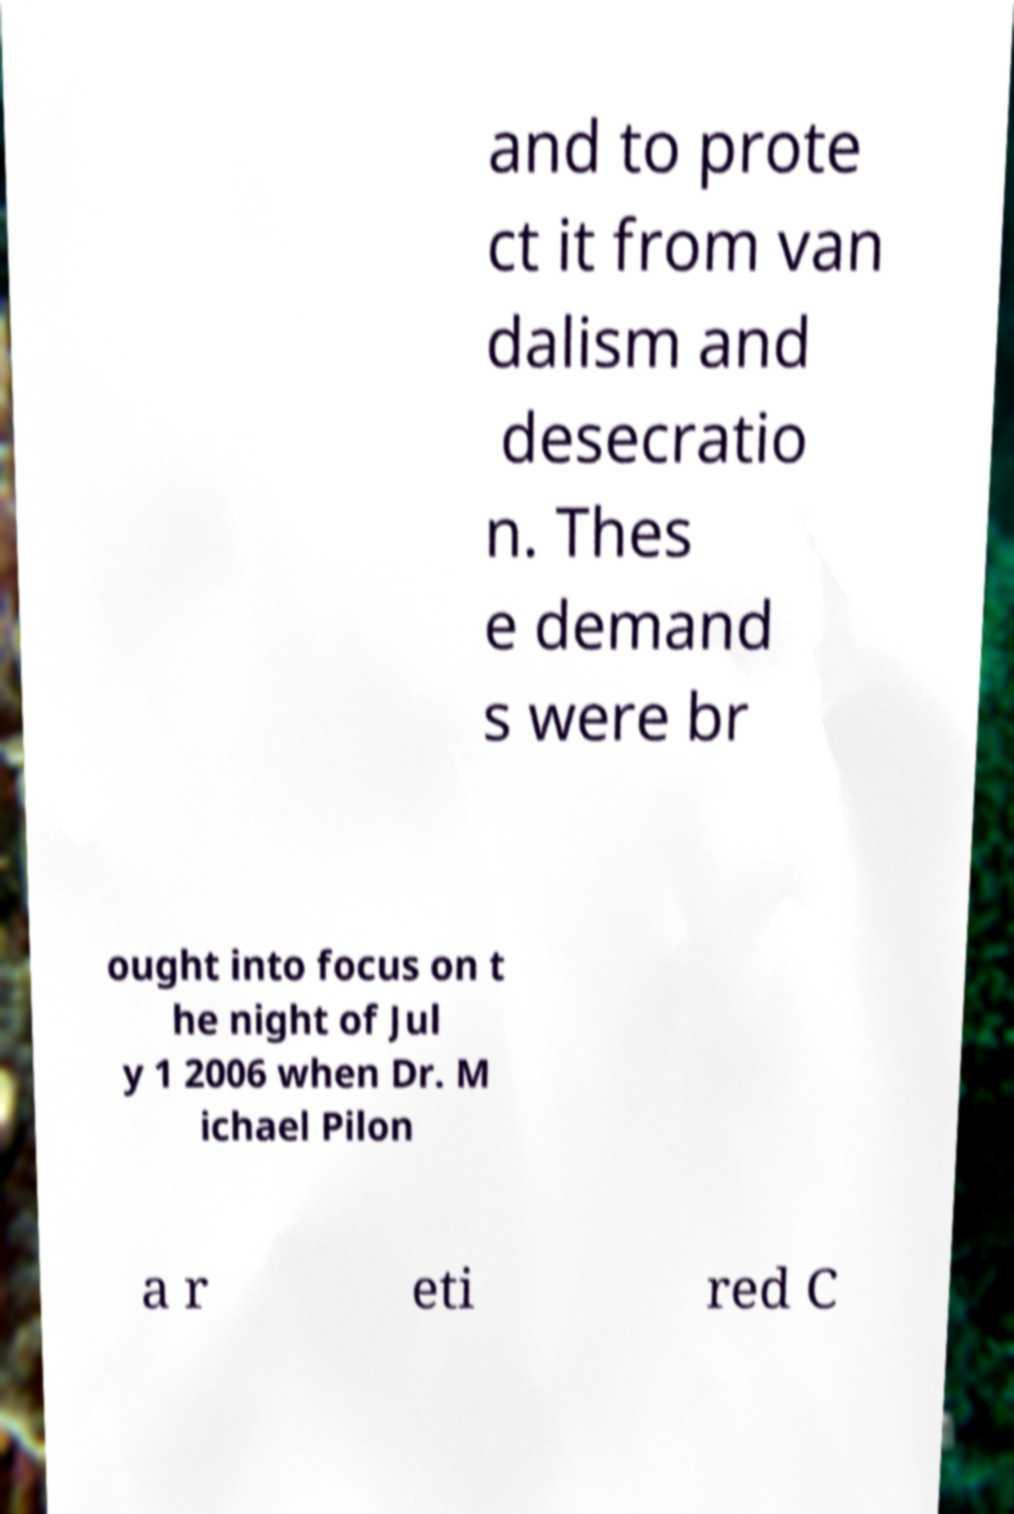Could you extract and type out the text from this image? and to prote ct it from van dalism and desecratio n. Thes e demand s were br ought into focus on t he night of Jul y 1 2006 when Dr. M ichael Pilon a r eti red C 